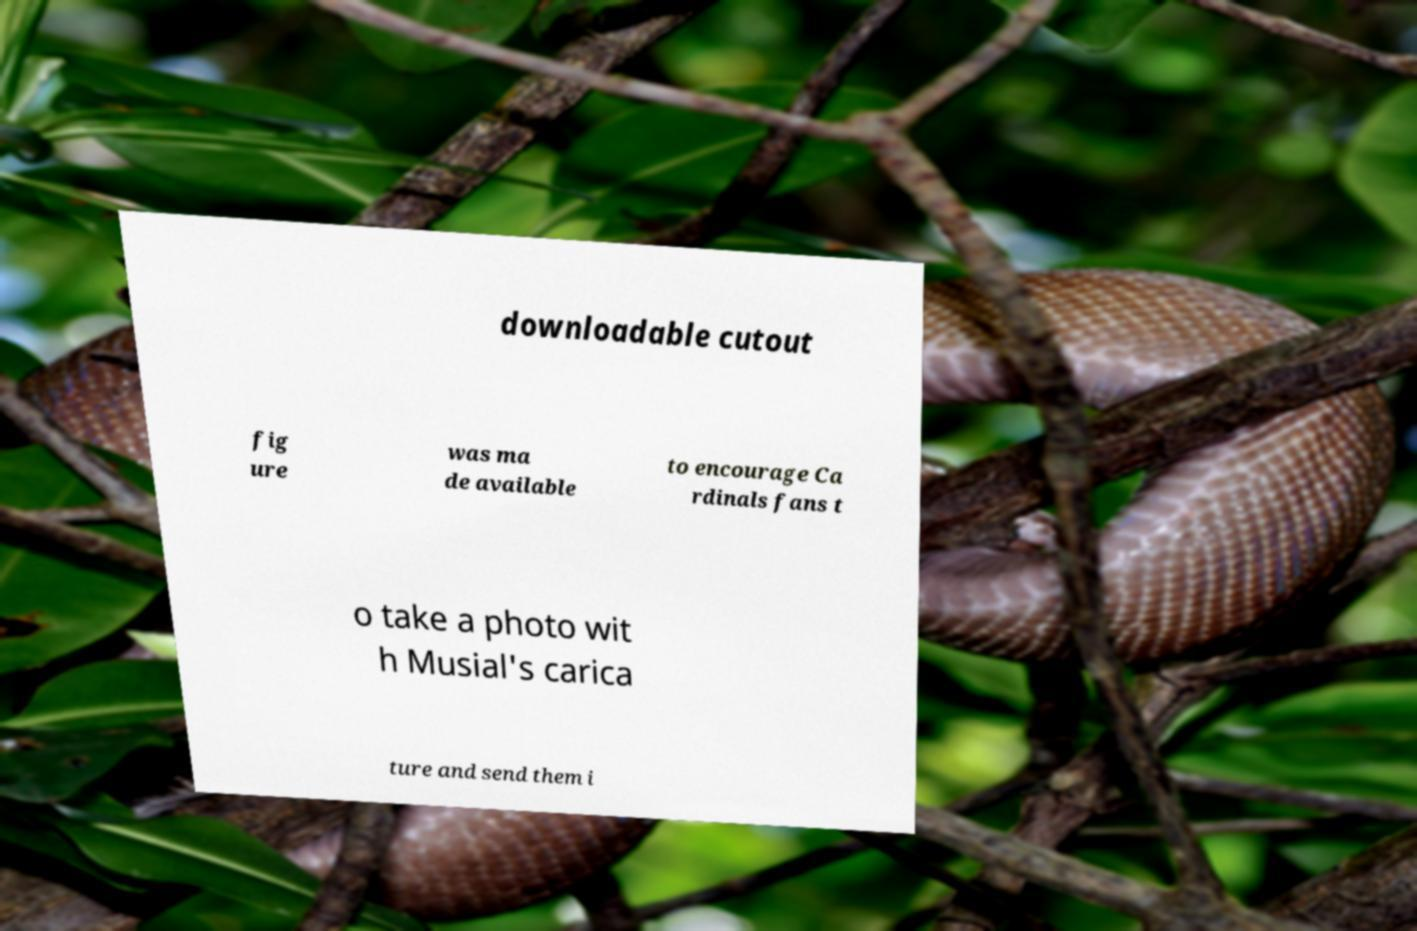Please read and relay the text visible in this image. What does it say? downloadable cutout fig ure was ma de available to encourage Ca rdinals fans t o take a photo wit h Musial's carica ture and send them i 